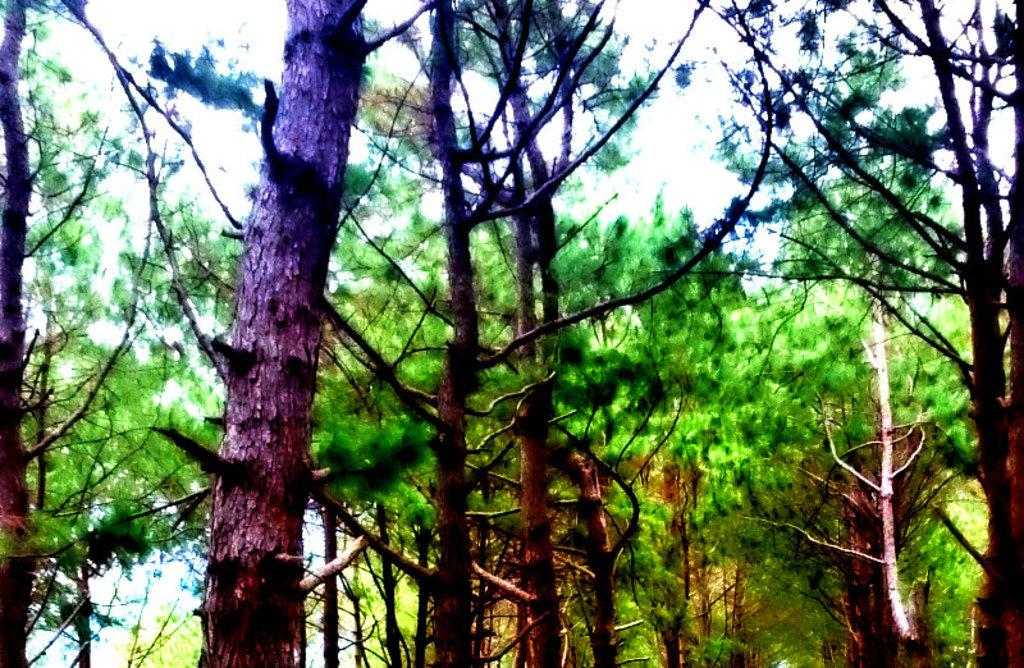What type of vegetation is visible in the image? There is a group of trees in the image. What is visible at the top of the image? The sky is visible at the top of the image. What type of quilt is being used to cover the trees in the image? There is no quilt present in the image; it features a group of trees and the sky. What type of sound can be heard coming from the trees in the image? There is no sound present in the image, as it is a static visual representation. 